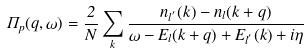<formula> <loc_0><loc_0><loc_500><loc_500>\Pi _ { p } ( { q } , \omega ) = \frac { 2 } { N } \sum _ { k } \frac { n _ { l ^ { ^ { \prime } } } ( k ) - n _ { l } ( k + q ) } { \omega - E _ { l } ( { k } + { q } ) + E _ { l ^ { ^ { \prime } } } ( { k } ) + i \eta }</formula> 